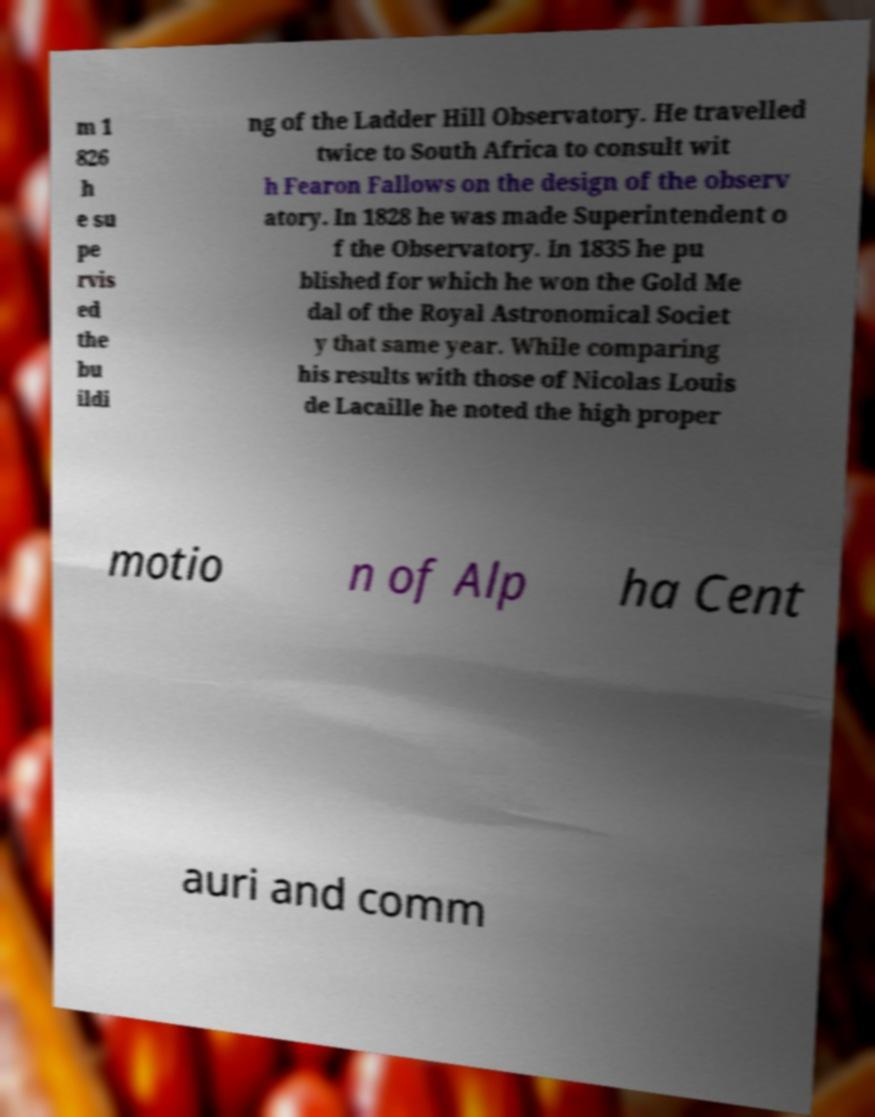Could you extract and type out the text from this image? m 1 826 h e su pe rvis ed the bu ildi ng of the Ladder Hill Observatory. He travelled twice to South Africa to consult wit h Fearon Fallows on the design of the observ atory. In 1828 he was made Superintendent o f the Observatory. In 1835 he pu blished for which he won the Gold Me dal of the Royal Astronomical Societ y that same year. While comparing his results with those of Nicolas Louis de Lacaille he noted the high proper motio n of Alp ha Cent auri and comm 